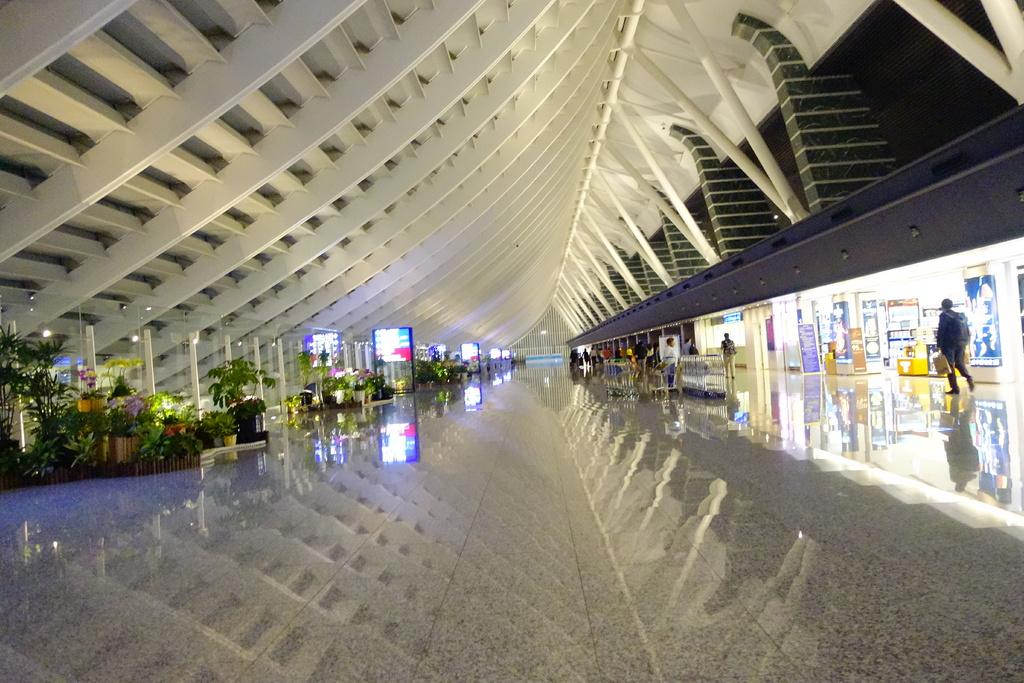How many persons can be seen in the image? There are persons in the image, but the exact number is not specified. What type of establishments are present in the image? There are shops in the image. What appliance can be seen in the image? There is a refrigerator in the image. What type of electronic devices are visible in the image? There are screens in the image. What type of natural elements are present in the image? There are trees and plants in the image. What type of architectural feature is present in the image? There are pillars in the image. What type of detail can be seen on the baby's clothing in the image? There is no baby present in the image, so there are no details on a baby's clothing to observe. 